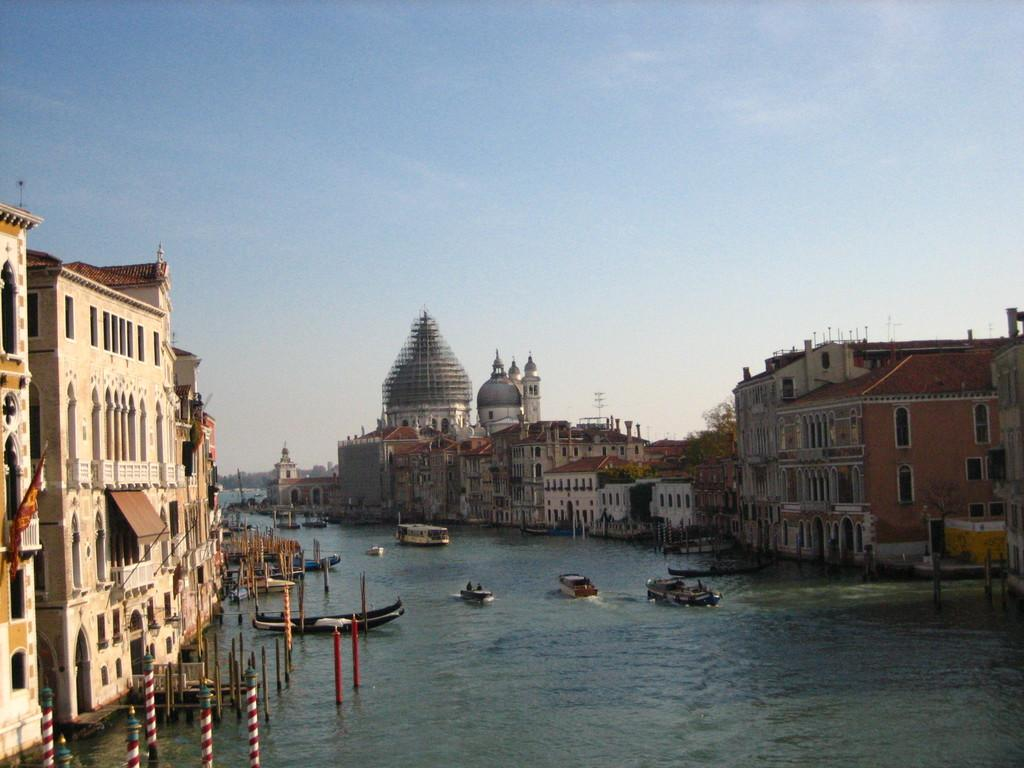What is the main subject in the center of the image? There is water in the center of the image. What is happening on the water? Boats are sailing on the water. What can be seen on the left side of the image? There are buildings and poles on the left side of the image. What can be seen on the right side of the image? There are buildings on the right side of the image. What type of cracker is being used to solve arithmetic problems in the image? There is no cracker or arithmetic problem present in the image. What color of yarn is being used to decorate the buildings in the image? There is no yarn present in the image; the buildings are not decorated with yarn. 